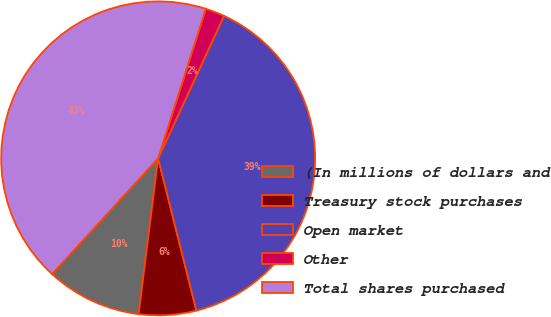Convert chart to OTSL. <chart><loc_0><loc_0><loc_500><loc_500><pie_chart><fcel>(In millions of dollars and<fcel>Treasury stock purchases<fcel>Open market<fcel>Other<fcel>Total shares purchased<nl><fcel>9.82%<fcel>5.9%<fcel>39.19%<fcel>1.98%<fcel>43.11%<nl></chart> 